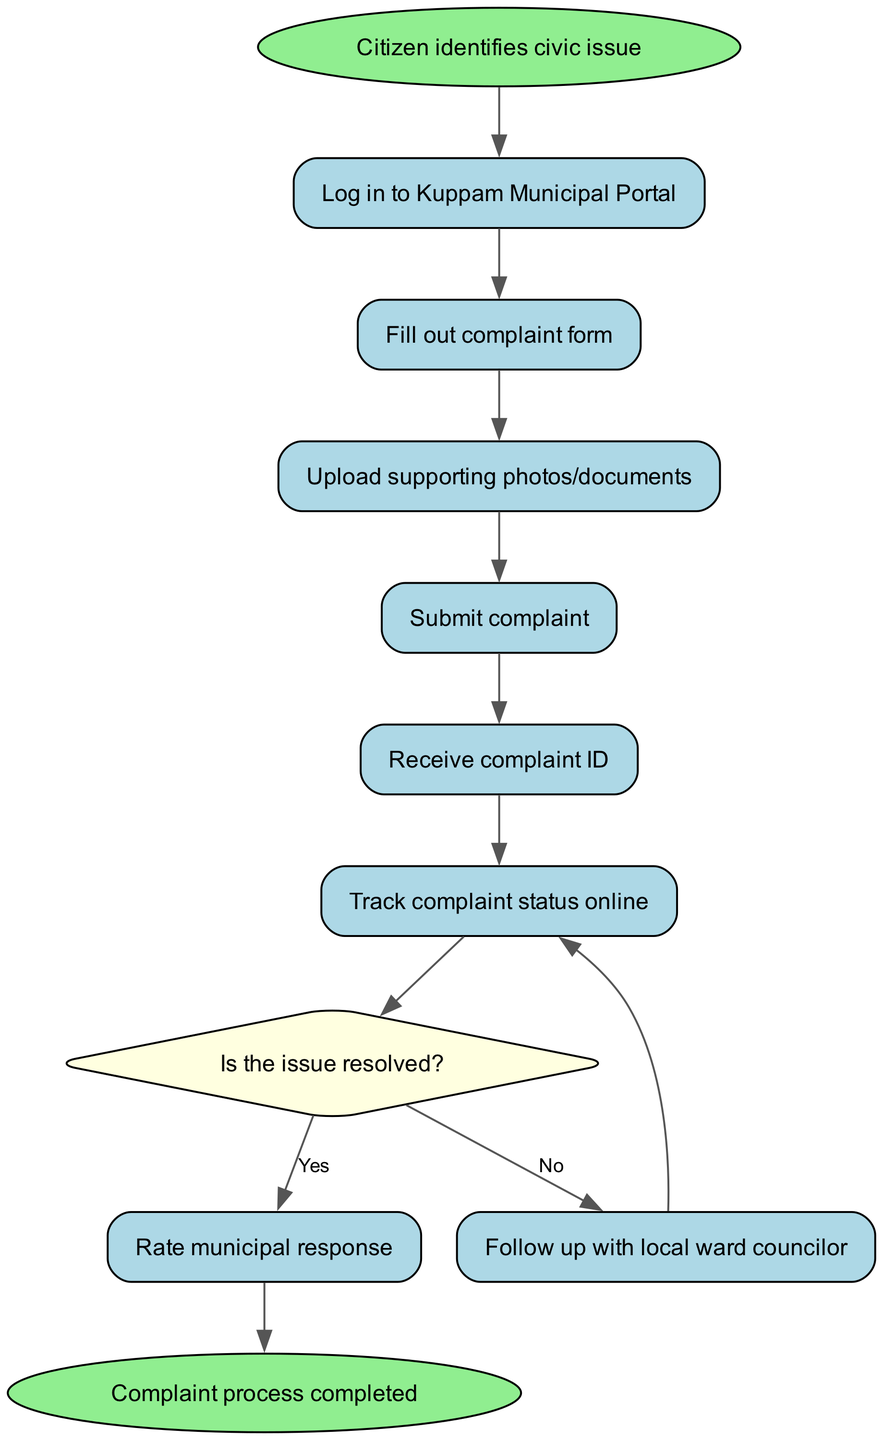What is the first step in the workflow? The diagram shows that the first step is when the citizen identifies a civic issue. This is represented by the node labeled "Citizen identifies civic issue" connected to the next step in the workflow.
Answer: Citizen identifies civic issue How many total steps are there in the workflow? By counting the distinct nodes in the diagram, we find a total of 7 steps (including decision nodes) from the start to the end of the workflow.
Answer: 7 What do citizens receive after submitting a complaint? The diagram indicates that after submitting the complaint, citizens receive a complaint ID, as stated in the node labeled "Receive complaint ID."
Answer: Complaint ID What happens if the issue is not resolved? Based on the diagram, if the issue is not resolved, the workflow leads to following up with the local ward councilor, as shown in the connection labeled "No" from the decision node.
Answer: Follow up with local ward councilor Which step follows after tracking the complaint status? The diagram shows that after tracking the complaint status online, the next step is to check if the issue is resolved, represented by the decision node.
Answer: Is the issue resolved? How many nodes represent actions taken by the citizen? In the diagram, there are 5 nodes that represent specific actions taken by the citizen: logging in, filling out the form, uploading documents, submitting the complaint, and tracking the status.
Answer: 5 What is the final outcome of the complaint process? According to the diagram, the final outcome or completion of the complaint process is represented by the node labeled "Complaint process completed."
Answer: Complaint process completed What action does the citizen take to give feedback? The diagram specifies that the citizen rates the municipal response as an action taken if the issue is resolved, depicted in the node following the decision labeled "Yes."
Answer: Rate municipal response What type of node is used to show the decision point in the workflow? The diagram utilizes a diamond-shaped node to denote the decision point regarding whether the issue is resolved or not. This can be confirmed by the shape and label in the diagram.
Answer: Diamond-shaped node 